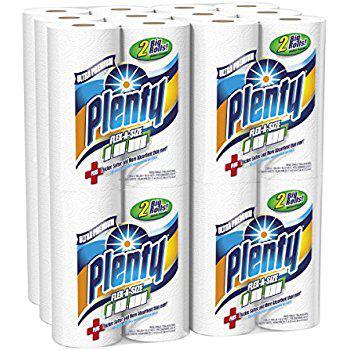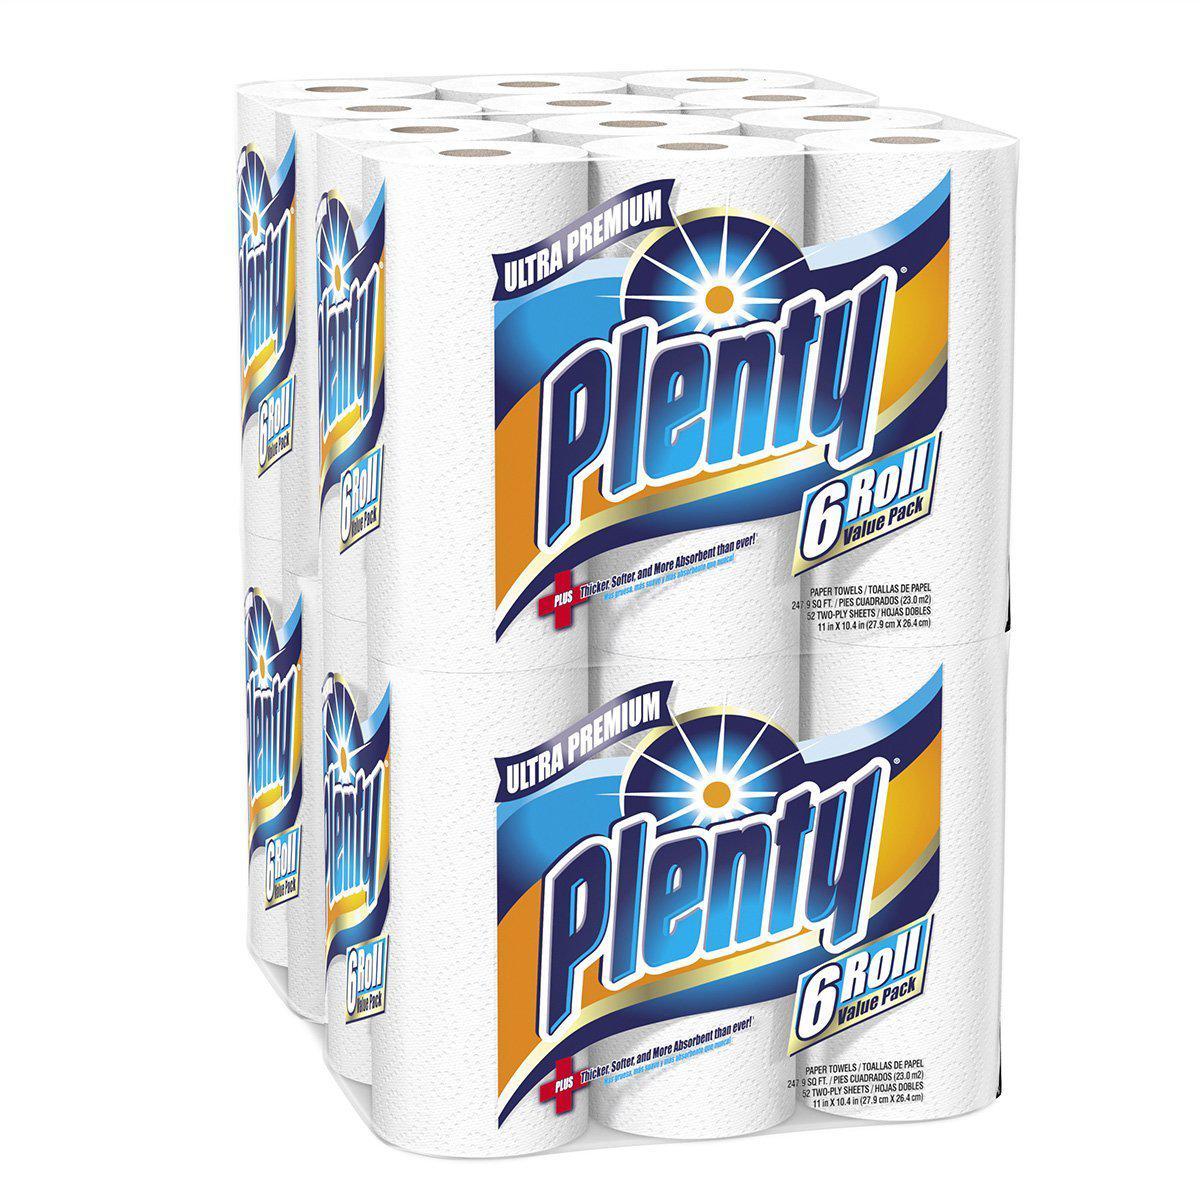The first image is the image on the left, the second image is the image on the right. Assess this claim about the two images: "Right and left images show paper towel packs with blue and orange colors on the packaging, all packs feature a sunburst, and at least one features a red plus-sign.". Correct or not? Answer yes or no. Yes. The first image is the image on the left, the second image is the image on the right. Assess this claim about the two images: "The package of paper towel in the image on the left contains more than 6 rolls.". Correct or not? Answer yes or no. Yes. 